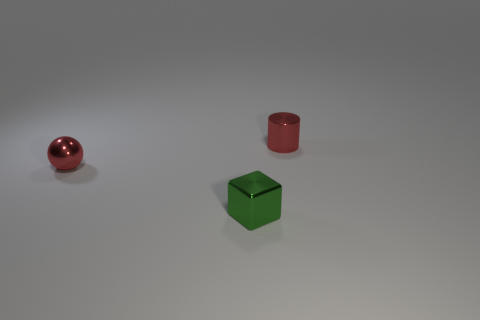There is a shiny thing that is the same color as the tiny cylinder; what is its size?
Offer a terse response. Small. Are any brown rubber cylinders visible?
Give a very brief answer. No. What shape is the tiny thing to the right of the green object to the right of the small red thing that is on the left side of the small green object?
Offer a terse response. Cylinder. How many green shiny cubes are in front of the small block?
Offer a very short reply. 0. Does the tiny green object right of the metal ball have the same material as the red cylinder?
Provide a short and direct response. Yes. What number of other objects are the same shape as the green metal object?
Give a very brief answer. 0. How many tiny cubes are right of the red metal cylinder on the right side of the red object that is on the left side of the tiny red cylinder?
Your response must be concise. 0. What is the color of the ball behind the tiny green shiny cube?
Give a very brief answer. Red. There is a metal thing that is in front of the red sphere; does it have the same color as the tiny cylinder?
Your answer should be compact. No. Is there any other thing that is the same size as the red shiny cylinder?
Offer a terse response. Yes. 